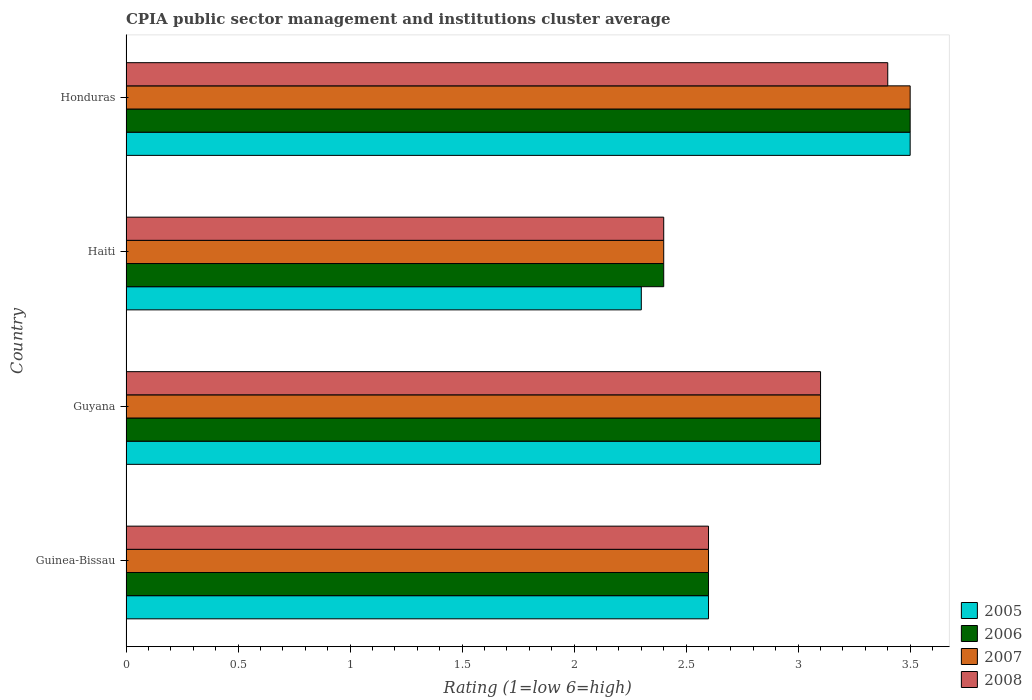How many different coloured bars are there?
Offer a terse response. 4. How many groups of bars are there?
Keep it short and to the point. 4. What is the label of the 1st group of bars from the top?
Offer a terse response. Honduras. In how many cases, is the number of bars for a given country not equal to the number of legend labels?
Ensure brevity in your answer.  0. In which country was the CPIA rating in 2006 maximum?
Ensure brevity in your answer.  Honduras. In which country was the CPIA rating in 2005 minimum?
Make the answer very short. Haiti. What is the total CPIA rating in 2007 in the graph?
Provide a short and direct response. 11.6. What is the difference between the CPIA rating in 2005 in Haiti and that in Honduras?
Ensure brevity in your answer.  -1.2. What is the difference between the CPIA rating in 2006 in Haiti and the CPIA rating in 2007 in Guinea-Bissau?
Make the answer very short. -0.2. What is the average CPIA rating in 2005 per country?
Make the answer very short. 2.88. In how many countries, is the CPIA rating in 2006 greater than 2.5 ?
Make the answer very short. 3. What is the ratio of the CPIA rating in 2008 in Guyana to that in Honduras?
Provide a short and direct response. 0.91. Is the CPIA rating in 2008 in Guinea-Bissau less than that in Honduras?
Offer a very short reply. Yes. Is the difference between the CPIA rating in 2008 in Guyana and Honduras greater than the difference between the CPIA rating in 2006 in Guyana and Honduras?
Give a very brief answer. Yes. What is the difference between the highest and the second highest CPIA rating in 2008?
Your answer should be very brief. 0.3. What is the difference between the highest and the lowest CPIA rating in 2005?
Provide a short and direct response. 1.2. Is the sum of the CPIA rating in 2006 in Guyana and Haiti greater than the maximum CPIA rating in 2005 across all countries?
Provide a succinct answer. Yes. Is it the case that in every country, the sum of the CPIA rating in 2005 and CPIA rating in 2006 is greater than the sum of CPIA rating in 2007 and CPIA rating in 2008?
Your answer should be very brief. No. What does the 4th bar from the bottom in Honduras represents?
Your answer should be very brief. 2008. Are all the bars in the graph horizontal?
Provide a succinct answer. Yes. What is the difference between two consecutive major ticks on the X-axis?
Your answer should be very brief. 0.5. Are the values on the major ticks of X-axis written in scientific E-notation?
Your answer should be compact. No. Where does the legend appear in the graph?
Provide a short and direct response. Bottom right. How are the legend labels stacked?
Your answer should be compact. Vertical. What is the title of the graph?
Keep it short and to the point. CPIA public sector management and institutions cluster average. Does "1988" appear as one of the legend labels in the graph?
Ensure brevity in your answer.  No. What is the Rating (1=low 6=high) in 2005 in Guinea-Bissau?
Provide a short and direct response. 2.6. What is the Rating (1=low 6=high) in 2008 in Guinea-Bissau?
Keep it short and to the point. 2.6. What is the Rating (1=low 6=high) of 2005 in Guyana?
Your answer should be very brief. 3.1. What is the Rating (1=low 6=high) of 2006 in Guyana?
Give a very brief answer. 3.1. What is the Rating (1=low 6=high) in 2005 in Haiti?
Provide a succinct answer. 2.3. What is the Rating (1=low 6=high) of 2008 in Haiti?
Your answer should be compact. 2.4. What is the Rating (1=low 6=high) in 2007 in Honduras?
Ensure brevity in your answer.  3.5. Across all countries, what is the maximum Rating (1=low 6=high) of 2006?
Your answer should be compact. 3.5. Across all countries, what is the minimum Rating (1=low 6=high) of 2005?
Your answer should be compact. 2.3. Across all countries, what is the minimum Rating (1=low 6=high) of 2008?
Provide a short and direct response. 2.4. What is the total Rating (1=low 6=high) in 2006 in the graph?
Offer a very short reply. 11.6. What is the total Rating (1=low 6=high) of 2008 in the graph?
Provide a succinct answer. 11.5. What is the difference between the Rating (1=low 6=high) of 2005 in Guinea-Bissau and that in Guyana?
Provide a succinct answer. -0.5. What is the difference between the Rating (1=low 6=high) of 2006 in Guinea-Bissau and that in Guyana?
Give a very brief answer. -0.5. What is the difference between the Rating (1=low 6=high) in 2006 in Guinea-Bissau and that in Haiti?
Provide a succinct answer. 0.2. What is the difference between the Rating (1=low 6=high) in 2006 in Guinea-Bissau and that in Honduras?
Provide a succinct answer. -0.9. What is the difference between the Rating (1=low 6=high) of 2007 in Guinea-Bissau and that in Honduras?
Your answer should be compact. -0.9. What is the difference between the Rating (1=low 6=high) of 2008 in Guinea-Bissau and that in Honduras?
Provide a succinct answer. -0.8. What is the difference between the Rating (1=low 6=high) of 2005 in Guyana and that in Haiti?
Your answer should be compact. 0.8. What is the difference between the Rating (1=low 6=high) of 2007 in Guyana and that in Haiti?
Keep it short and to the point. 0.7. What is the difference between the Rating (1=low 6=high) of 2005 in Guyana and that in Honduras?
Keep it short and to the point. -0.4. What is the difference between the Rating (1=low 6=high) of 2008 in Guyana and that in Honduras?
Offer a terse response. -0.3. What is the difference between the Rating (1=low 6=high) in 2006 in Haiti and that in Honduras?
Give a very brief answer. -1.1. What is the difference between the Rating (1=low 6=high) in 2007 in Haiti and that in Honduras?
Keep it short and to the point. -1.1. What is the difference between the Rating (1=low 6=high) in 2005 in Guinea-Bissau and the Rating (1=low 6=high) in 2006 in Guyana?
Offer a terse response. -0.5. What is the difference between the Rating (1=low 6=high) in 2005 in Guinea-Bissau and the Rating (1=low 6=high) in 2007 in Guyana?
Your answer should be compact. -0.5. What is the difference between the Rating (1=low 6=high) of 2005 in Guinea-Bissau and the Rating (1=low 6=high) of 2008 in Guyana?
Keep it short and to the point. -0.5. What is the difference between the Rating (1=low 6=high) in 2005 in Guinea-Bissau and the Rating (1=low 6=high) in 2006 in Haiti?
Offer a very short reply. 0.2. What is the difference between the Rating (1=low 6=high) in 2005 in Guinea-Bissau and the Rating (1=low 6=high) in 2008 in Haiti?
Provide a short and direct response. 0.2. What is the difference between the Rating (1=low 6=high) in 2005 in Guinea-Bissau and the Rating (1=low 6=high) in 2006 in Honduras?
Give a very brief answer. -0.9. What is the difference between the Rating (1=low 6=high) in 2005 in Guinea-Bissau and the Rating (1=low 6=high) in 2007 in Honduras?
Provide a short and direct response. -0.9. What is the difference between the Rating (1=low 6=high) of 2006 in Guinea-Bissau and the Rating (1=low 6=high) of 2007 in Honduras?
Make the answer very short. -0.9. What is the difference between the Rating (1=low 6=high) in 2006 in Guinea-Bissau and the Rating (1=low 6=high) in 2008 in Honduras?
Offer a very short reply. -0.8. What is the difference between the Rating (1=low 6=high) of 2007 in Guinea-Bissau and the Rating (1=low 6=high) of 2008 in Honduras?
Make the answer very short. -0.8. What is the difference between the Rating (1=low 6=high) in 2005 in Guyana and the Rating (1=low 6=high) in 2006 in Haiti?
Offer a very short reply. 0.7. What is the difference between the Rating (1=low 6=high) in 2005 in Guyana and the Rating (1=low 6=high) in 2008 in Haiti?
Give a very brief answer. 0.7. What is the difference between the Rating (1=low 6=high) in 2006 in Guyana and the Rating (1=low 6=high) in 2007 in Haiti?
Provide a succinct answer. 0.7. What is the difference between the Rating (1=low 6=high) of 2007 in Guyana and the Rating (1=low 6=high) of 2008 in Haiti?
Give a very brief answer. 0.7. What is the difference between the Rating (1=low 6=high) of 2005 in Guyana and the Rating (1=low 6=high) of 2006 in Honduras?
Keep it short and to the point. -0.4. What is the difference between the Rating (1=low 6=high) in 2006 in Guyana and the Rating (1=low 6=high) in 2007 in Honduras?
Provide a short and direct response. -0.4. What is the difference between the Rating (1=low 6=high) of 2007 in Guyana and the Rating (1=low 6=high) of 2008 in Honduras?
Make the answer very short. -0.3. What is the difference between the Rating (1=low 6=high) in 2005 in Haiti and the Rating (1=low 6=high) in 2007 in Honduras?
Make the answer very short. -1.2. What is the difference between the Rating (1=low 6=high) in 2007 in Haiti and the Rating (1=low 6=high) in 2008 in Honduras?
Give a very brief answer. -1. What is the average Rating (1=low 6=high) in 2005 per country?
Provide a succinct answer. 2.88. What is the average Rating (1=low 6=high) of 2008 per country?
Offer a terse response. 2.88. What is the difference between the Rating (1=low 6=high) in 2005 and Rating (1=low 6=high) in 2008 in Guinea-Bissau?
Your answer should be compact. 0. What is the difference between the Rating (1=low 6=high) in 2006 and Rating (1=low 6=high) in 2008 in Guinea-Bissau?
Provide a short and direct response. 0. What is the difference between the Rating (1=low 6=high) in 2007 and Rating (1=low 6=high) in 2008 in Guyana?
Your answer should be compact. 0. What is the difference between the Rating (1=low 6=high) in 2005 and Rating (1=low 6=high) in 2006 in Haiti?
Offer a very short reply. -0.1. What is the difference between the Rating (1=low 6=high) of 2005 and Rating (1=low 6=high) of 2007 in Haiti?
Ensure brevity in your answer.  -0.1. What is the difference between the Rating (1=low 6=high) of 2006 and Rating (1=low 6=high) of 2007 in Haiti?
Provide a succinct answer. 0. What is the difference between the Rating (1=low 6=high) of 2006 and Rating (1=low 6=high) of 2008 in Haiti?
Your answer should be compact. 0. What is the difference between the Rating (1=low 6=high) of 2005 and Rating (1=low 6=high) of 2006 in Honduras?
Offer a terse response. 0. What is the difference between the Rating (1=low 6=high) of 2005 and Rating (1=low 6=high) of 2007 in Honduras?
Your answer should be compact. 0. What is the difference between the Rating (1=low 6=high) in 2006 and Rating (1=low 6=high) in 2007 in Honduras?
Offer a terse response. 0. What is the ratio of the Rating (1=low 6=high) of 2005 in Guinea-Bissau to that in Guyana?
Make the answer very short. 0.84. What is the ratio of the Rating (1=low 6=high) in 2006 in Guinea-Bissau to that in Guyana?
Your answer should be very brief. 0.84. What is the ratio of the Rating (1=low 6=high) in 2007 in Guinea-Bissau to that in Guyana?
Offer a terse response. 0.84. What is the ratio of the Rating (1=low 6=high) in 2008 in Guinea-Bissau to that in Guyana?
Make the answer very short. 0.84. What is the ratio of the Rating (1=low 6=high) of 2005 in Guinea-Bissau to that in Haiti?
Provide a short and direct response. 1.13. What is the ratio of the Rating (1=low 6=high) in 2006 in Guinea-Bissau to that in Haiti?
Your response must be concise. 1.08. What is the ratio of the Rating (1=low 6=high) in 2007 in Guinea-Bissau to that in Haiti?
Provide a succinct answer. 1.08. What is the ratio of the Rating (1=low 6=high) in 2008 in Guinea-Bissau to that in Haiti?
Keep it short and to the point. 1.08. What is the ratio of the Rating (1=low 6=high) of 2005 in Guinea-Bissau to that in Honduras?
Offer a terse response. 0.74. What is the ratio of the Rating (1=low 6=high) of 2006 in Guinea-Bissau to that in Honduras?
Make the answer very short. 0.74. What is the ratio of the Rating (1=low 6=high) of 2007 in Guinea-Bissau to that in Honduras?
Provide a succinct answer. 0.74. What is the ratio of the Rating (1=low 6=high) in 2008 in Guinea-Bissau to that in Honduras?
Provide a succinct answer. 0.76. What is the ratio of the Rating (1=low 6=high) in 2005 in Guyana to that in Haiti?
Keep it short and to the point. 1.35. What is the ratio of the Rating (1=low 6=high) in 2006 in Guyana to that in Haiti?
Your response must be concise. 1.29. What is the ratio of the Rating (1=low 6=high) of 2007 in Guyana to that in Haiti?
Keep it short and to the point. 1.29. What is the ratio of the Rating (1=low 6=high) of 2008 in Guyana to that in Haiti?
Your answer should be compact. 1.29. What is the ratio of the Rating (1=low 6=high) in 2005 in Guyana to that in Honduras?
Offer a very short reply. 0.89. What is the ratio of the Rating (1=low 6=high) of 2006 in Guyana to that in Honduras?
Offer a very short reply. 0.89. What is the ratio of the Rating (1=low 6=high) in 2007 in Guyana to that in Honduras?
Offer a terse response. 0.89. What is the ratio of the Rating (1=low 6=high) in 2008 in Guyana to that in Honduras?
Provide a succinct answer. 0.91. What is the ratio of the Rating (1=low 6=high) of 2005 in Haiti to that in Honduras?
Make the answer very short. 0.66. What is the ratio of the Rating (1=low 6=high) in 2006 in Haiti to that in Honduras?
Provide a short and direct response. 0.69. What is the ratio of the Rating (1=low 6=high) in 2007 in Haiti to that in Honduras?
Keep it short and to the point. 0.69. What is the ratio of the Rating (1=low 6=high) of 2008 in Haiti to that in Honduras?
Provide a succinct answer. 0.71. What is the difference between the highest and the second highest Rating (1=low 6=high) of 2005?
Ensure brevity in your answer.  0.4. What is the difference between the highest and the lowest Rating (1=low 6=high) of 2005?
Make the answer very short. 1.2. What is the difference between the highest and the lowest Rating (1=low 6=high) of 2006?
Your response must be concise. 1.1. What is the difference between the highest and the lowest Rating (1=low 6=high) in 2007?
Offer a terse response. 1.1. 